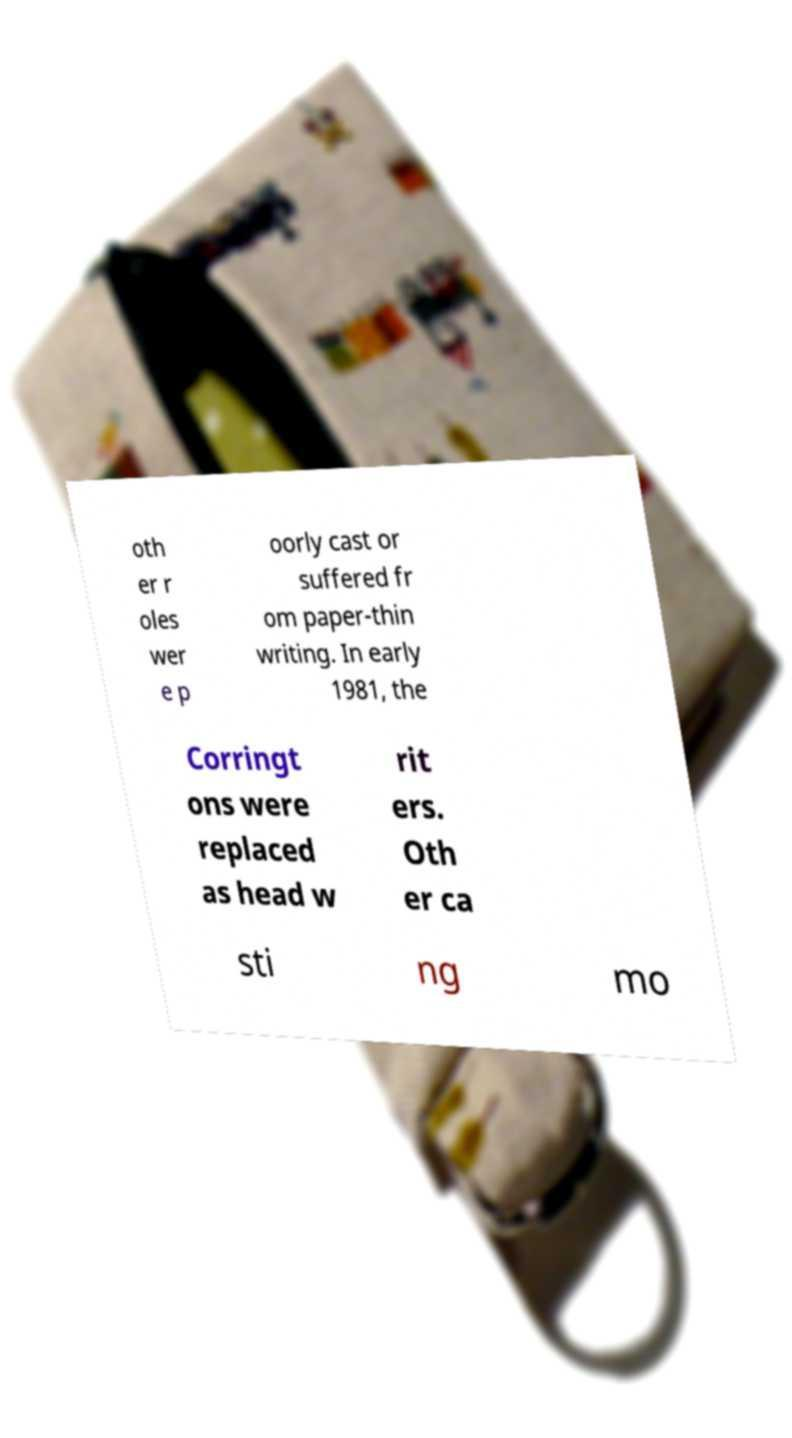I need the written content from this picture converted into text. Can you do that? oth er r oles wer e p oorly cast or suffered fr om paper-thin writing. In early 1981, the Corringt ons were replaced as head w rit ers. Oth er ca sti ng mo 